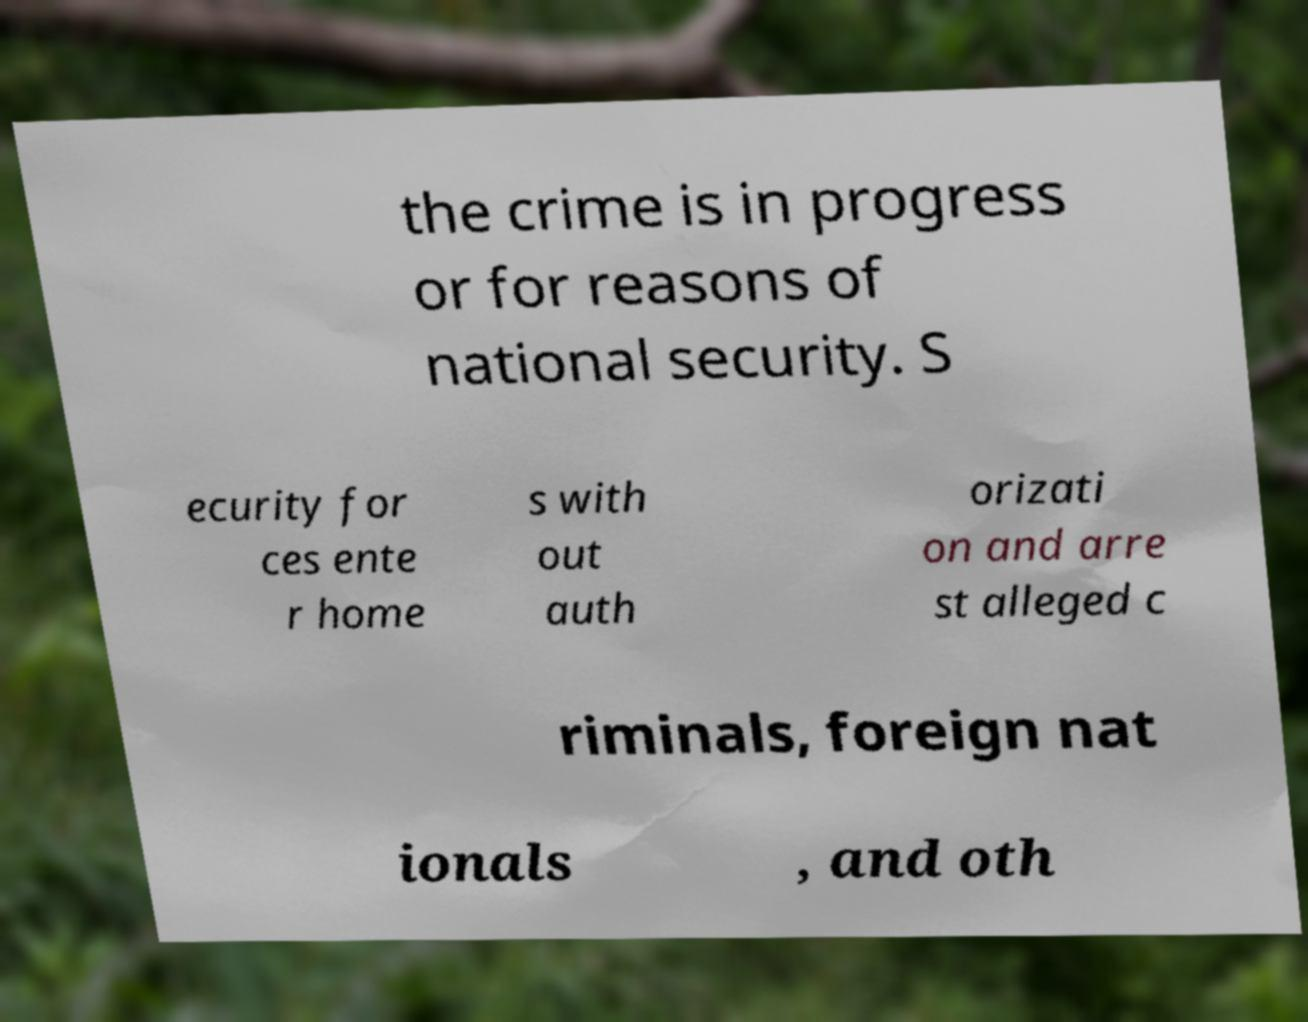Please identify and transcribe the text found in this image. the crime is in progress or for reasons of national security. S ecurity for ces ente r home s with out auth orizati on and arre st alleged c riminals, foreign nat ionals , and oth 